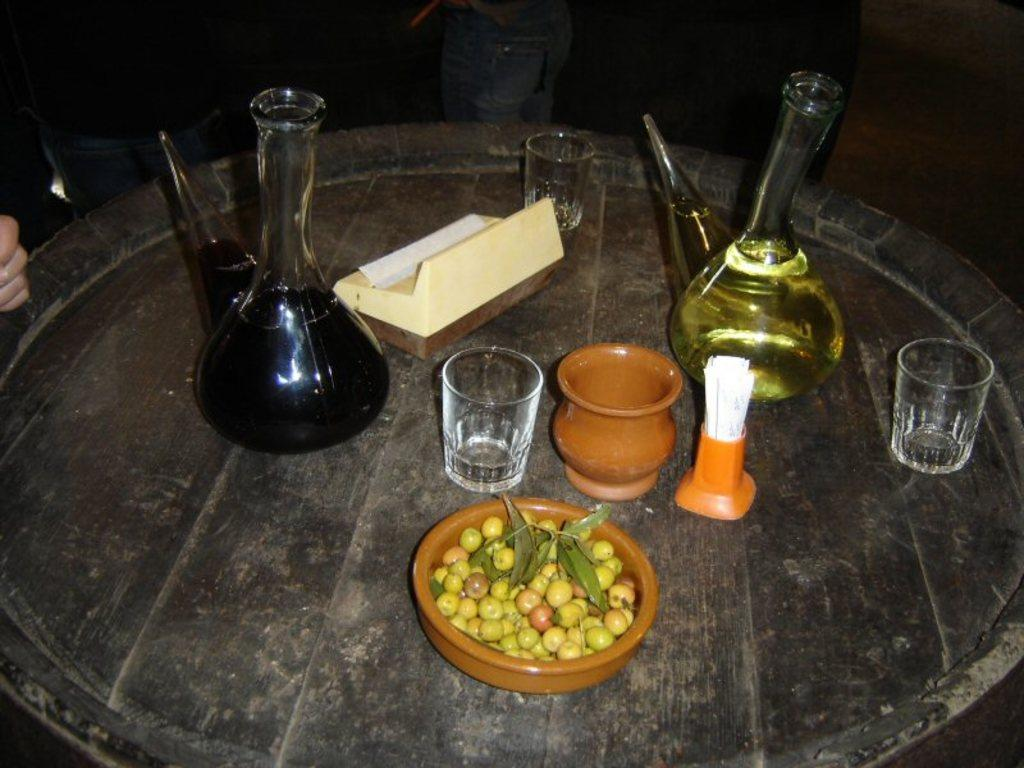What is the main structure in the image? There is a platform in the image. What items can be seen on the platform? Beakers, glasses, a pot, a bowl, food, a shaving brush, and a wooden object are present on the platform. What type of food is visible on the platform? The food visible on the platform is not specified in the facts. What else can be observed in the image? People's legs are visible in the background of the image. How does the tin react during the earthquake in the image? There is no tin or earthquake present in the image. What type of camp is set up in the image? There is no camp present in the image; it features a platform with various items on it. 